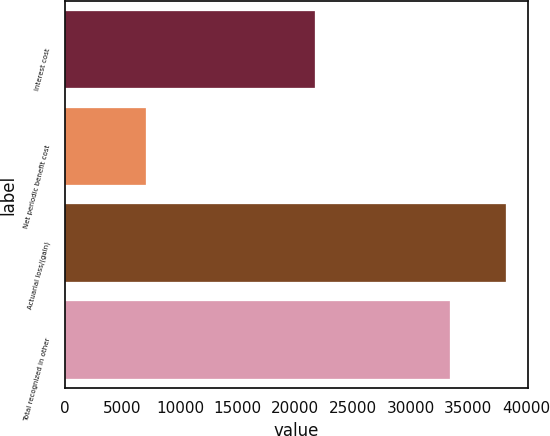<chart> <loc_0><loc_0><loc_500><loc_500><bar_chart><fcel>Interest cost<fcel>Net periodic benefit cost<fcel>Actuarial loss/(gain)<fcel>Total recognized in other<nl><fcel>21707<fcel>7068<fcel>38220<fcel>33423<nl></chart> 